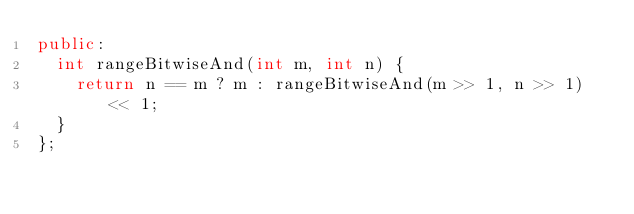Convert code to text. <code><loc_0><loc_0><loc_500><loc_500><_C++_>public:
  int rangeBitwiseAnd(int m, int n) {
    return n == m ? m : rangeBitwiseAnd(m >> 1, n >> 1) << 1;
  }
};
</code> 